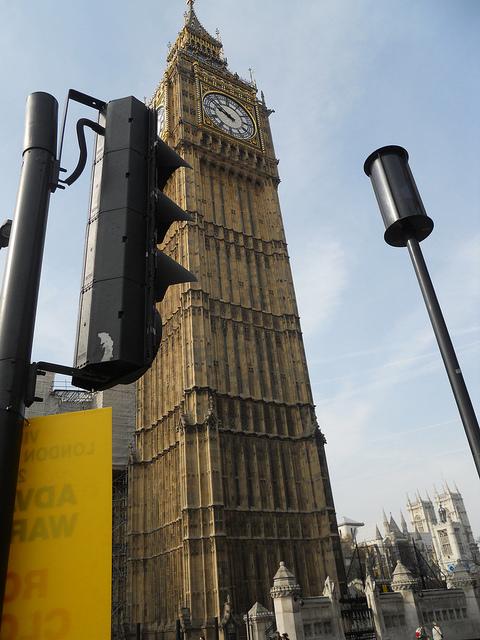What color is the sign on the left corner?
Keep it brief. Yellow. Is the traffic light truly almost as tall as the tower?
Short answer required. No. What color is the sign under the traffic light?
Keep it brief. Yellow. 